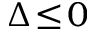<formula> <loc_0><loc_0><loc_500><loc_500>\Delta \, \leq \, 0</formula> 